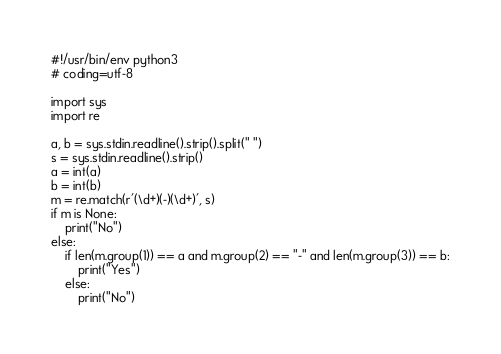<code> <loc_0><loc_0><loc_500><loc_500><_Python_>#!/usr/bin/env python3
# coding=utf-8

import sys
import re

a, b = sys.stdin.readline().strip().split(" ")
s = sys.stdin.readline().strip()
a = int(a)
b = int(b)
m = re.match(r'(\d+)(-)(\d+)', s)
if m is None:
    print("No")
else:
    if len(m.group(1)) == a and m.group(2) == "-" and len(m.group(3)) == b:
        print("Yes")
    else:
        print("No")
</code> 